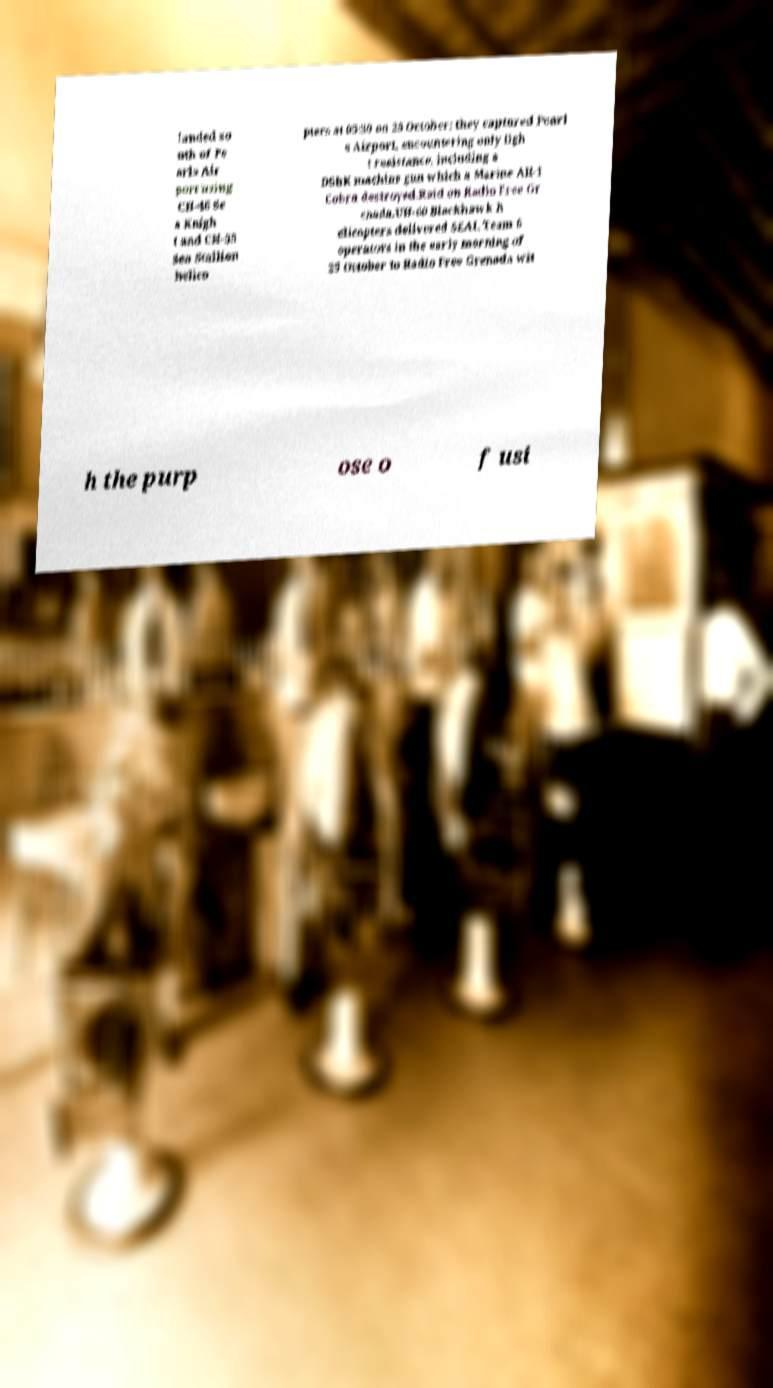Can you accurately transcribe the text from the provided image for me? landed so uth of Pe arls Air port using CH-46 Se a Knigh t and CH-53 Sea Stallion helico pters at 05:30 on 25 October; they captured Pearl s Airport, encountering only ligh t resistance, including a DShK machine gun which a Marine AH-1 Cobra destroyed.Raid on Radio Free Gr enada.UH-60 Blackhawk h elicopters delivered SEAL Team 6 operators in the early morning of 25 October to Radio Free Grenada wit h the purp ose o f usi 